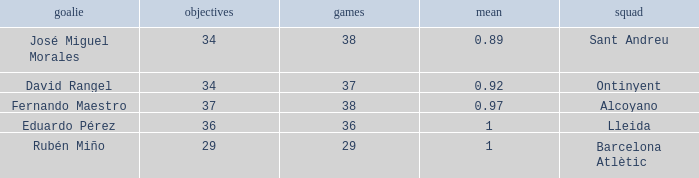What is the sum of Goals, when Matches is less than 29? None. Can you parse all the data within this table? {'header': ['goalie', 'objectives', 'games', 'mean', 'squad'], 'rows': [['José Miguel Morales', '34', '38', '0.89', 'Sant Andreu'], ['David Rangel', '34', '37', '0.92', 'Ontinyent'], ['Fernando Maestro', '37', '38', '0.97', 'Alcoyano'], ['Eduardo Pérez', '36', '36', '1', 'Lleida'], ['Rubén Miño', '29', '29', '1', 'Barcelona Atlètic']]} 